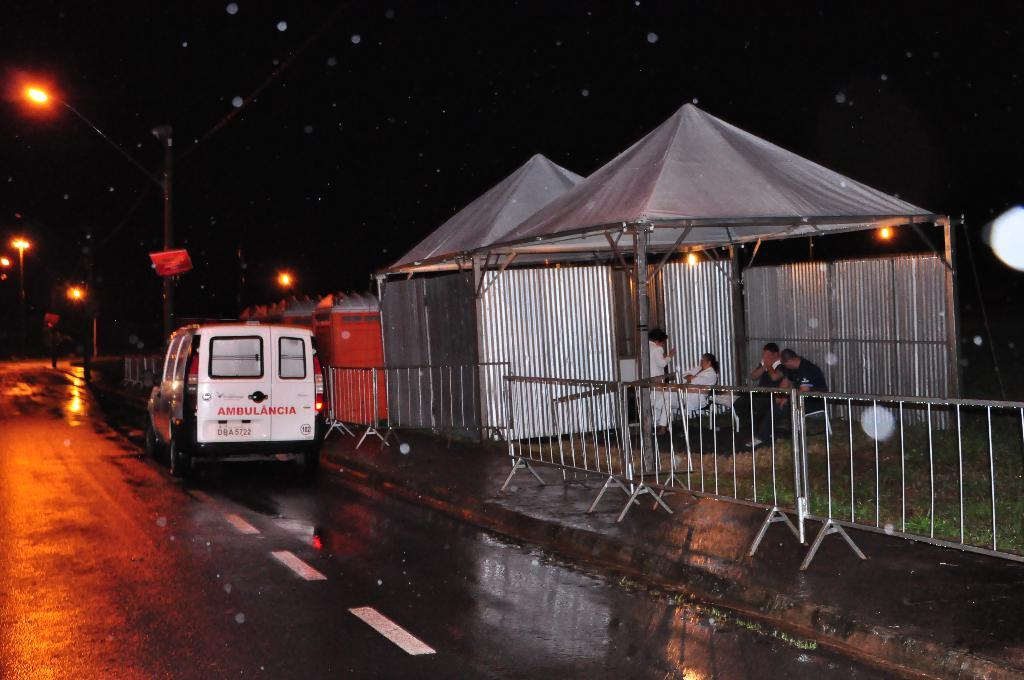What is on the road in the image? There is a vehicle on the road in the image. What type of barrier is present in the image? There is a metal fence in the image. What type of vegetation can be seen in the image? Grass is visible in the image. Where are the people in the image located? There is a group of people under a tent in the image. What type of structures are present in the image? Street poles are present in the image. What can be seen in the sky in the image? Lights are visible in the image. What is visible in the background of the image? The sky is visible in the image. Where is the nest located in the image? There is no nest present in the image. What type of furniture is visible in the image? There is no furniture visible in the image. 